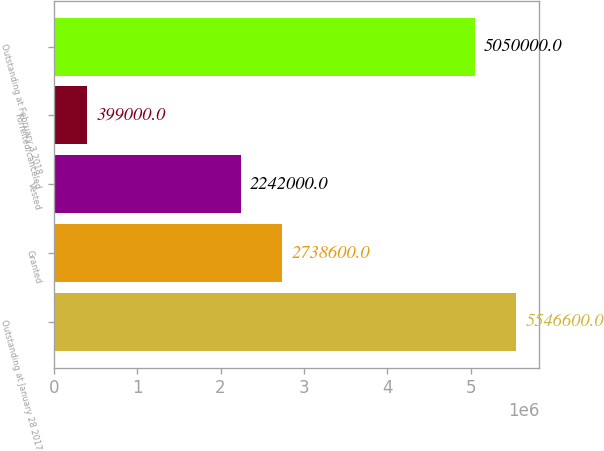Convert chart to OTSL. <chart><loc_0><loc_0><loc_500><loc_500><bar_chart><fcel>Outstanding at January 28 2017<fcel>Granted<fcel>Vested<fcel>Forfeited/canceled<fcel>Outstanding at February 3 2018<nl><fcel>5.5466e+06<fcel>2.7386e+06<fcel>2.242e+06<fcel>399000<fcel>5.05e+06<nl></chart> 